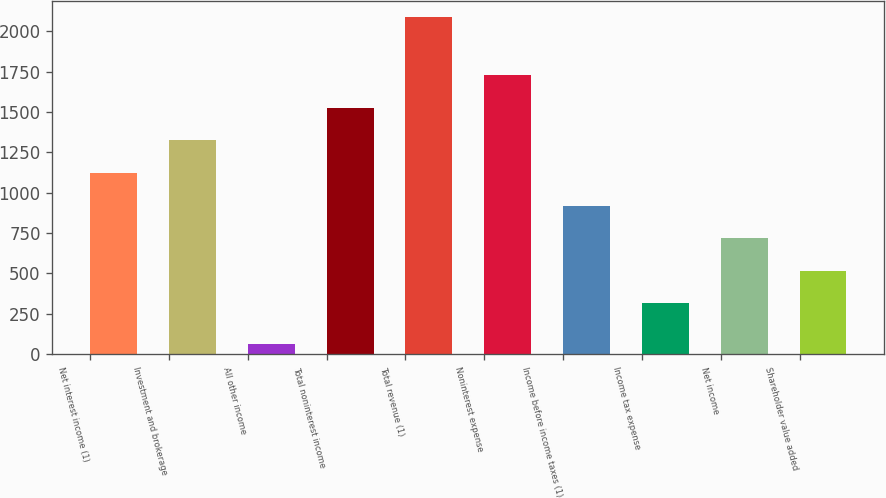Convert chart to OTSL. <chart><loc_0><loc_0><loc_500><loc_500><bar_chart><fcel>Net interest income (1)<fcel>Investment and brokerage<fcel>All other income<fcel>Total noninterest income<fcel>Total revenue (1)<fcel>Noninterest expense<fcel>Income before income taxes (1)<fcel>Income tax expense<fcel>Net income<fcel>Shareholder value added<nl><fcel>1122.8<fcel>1325<fcel>65<fcel>1527.2<fcel>2087<fcel>1729.4<fcel>920.6<fcel>314<fcel>718.4<fcel>516.2<nl></chart> 